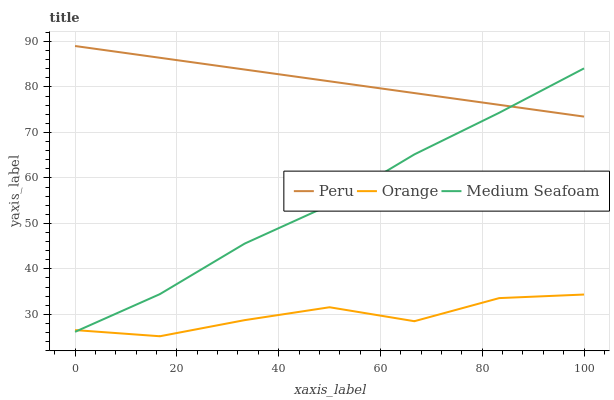Does Orange have the minimum area under the curve?
Answer yes or no. Yes. Does Peru have the maximum area under the curve?
Answer yes or no. Yes. Does Medium Seafoam have the minimum area under the curve?
Answer yes or no. No. Does Medium Seafoam have the maximum area under the curve?
Answer yes or no. No. Is Peru the smoothest?
Answer yes or no. Yes. Is Orange the roughest?
Answer yes or no. Yes. Is Medium Seafoam the smoothest?
Answer yes or no. No. Is Medium Seafoam the roughest?
Answer yes or no. No. Does Orange have the lowest value?
Answer yes or no. Yes. Does Medium Seafoam have the lowest value?
Answer yes or no. No. Does Peru have the highest value?
Answer yes or no. Yes. Does Medium Seafoam have the highest value?
Answer yes or no. No. Is Orange less than Peru?
Answer yes or no. Yes. Is Peru greater than Orange?
Answer yes or no. Yes. Does Peru intersect Medium Seafoam?
Answer yes or no. Yes. Is Peru less than Medium Seafoam?
Answer yes or no. No. Is Peru greater than Medium Seafoam?
Answer yes or no. No. Does Orange intersect Peru?
Answer yes or no. No. 